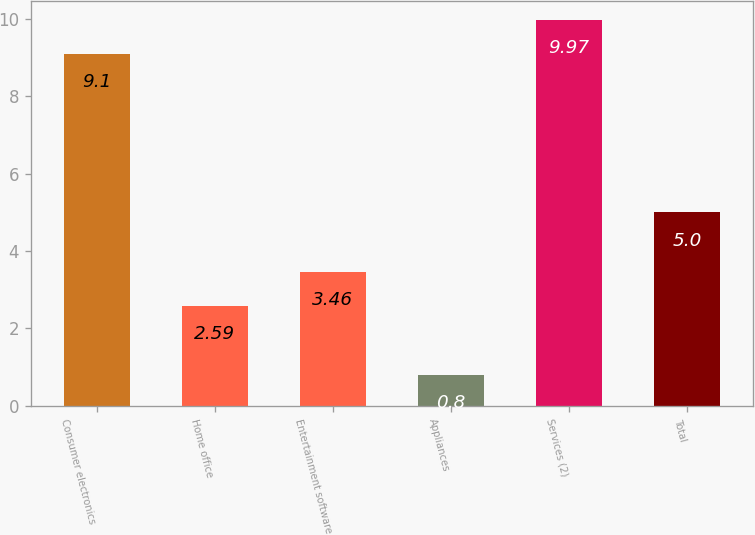Convert chart. <chart><loc_0><loc_0><loc_500><loc_500><bar_chart><fcel>Consumer electronics<fcel>Home office<fcel>Entertainment software<fcel>Appliances<fcel>Services (2)<fcel>Total<nl><fcel>9.1<fcel>2.59<fcel>3.46<fcel>0.8<fcel>9.97<fcel>5<nl></chart> 